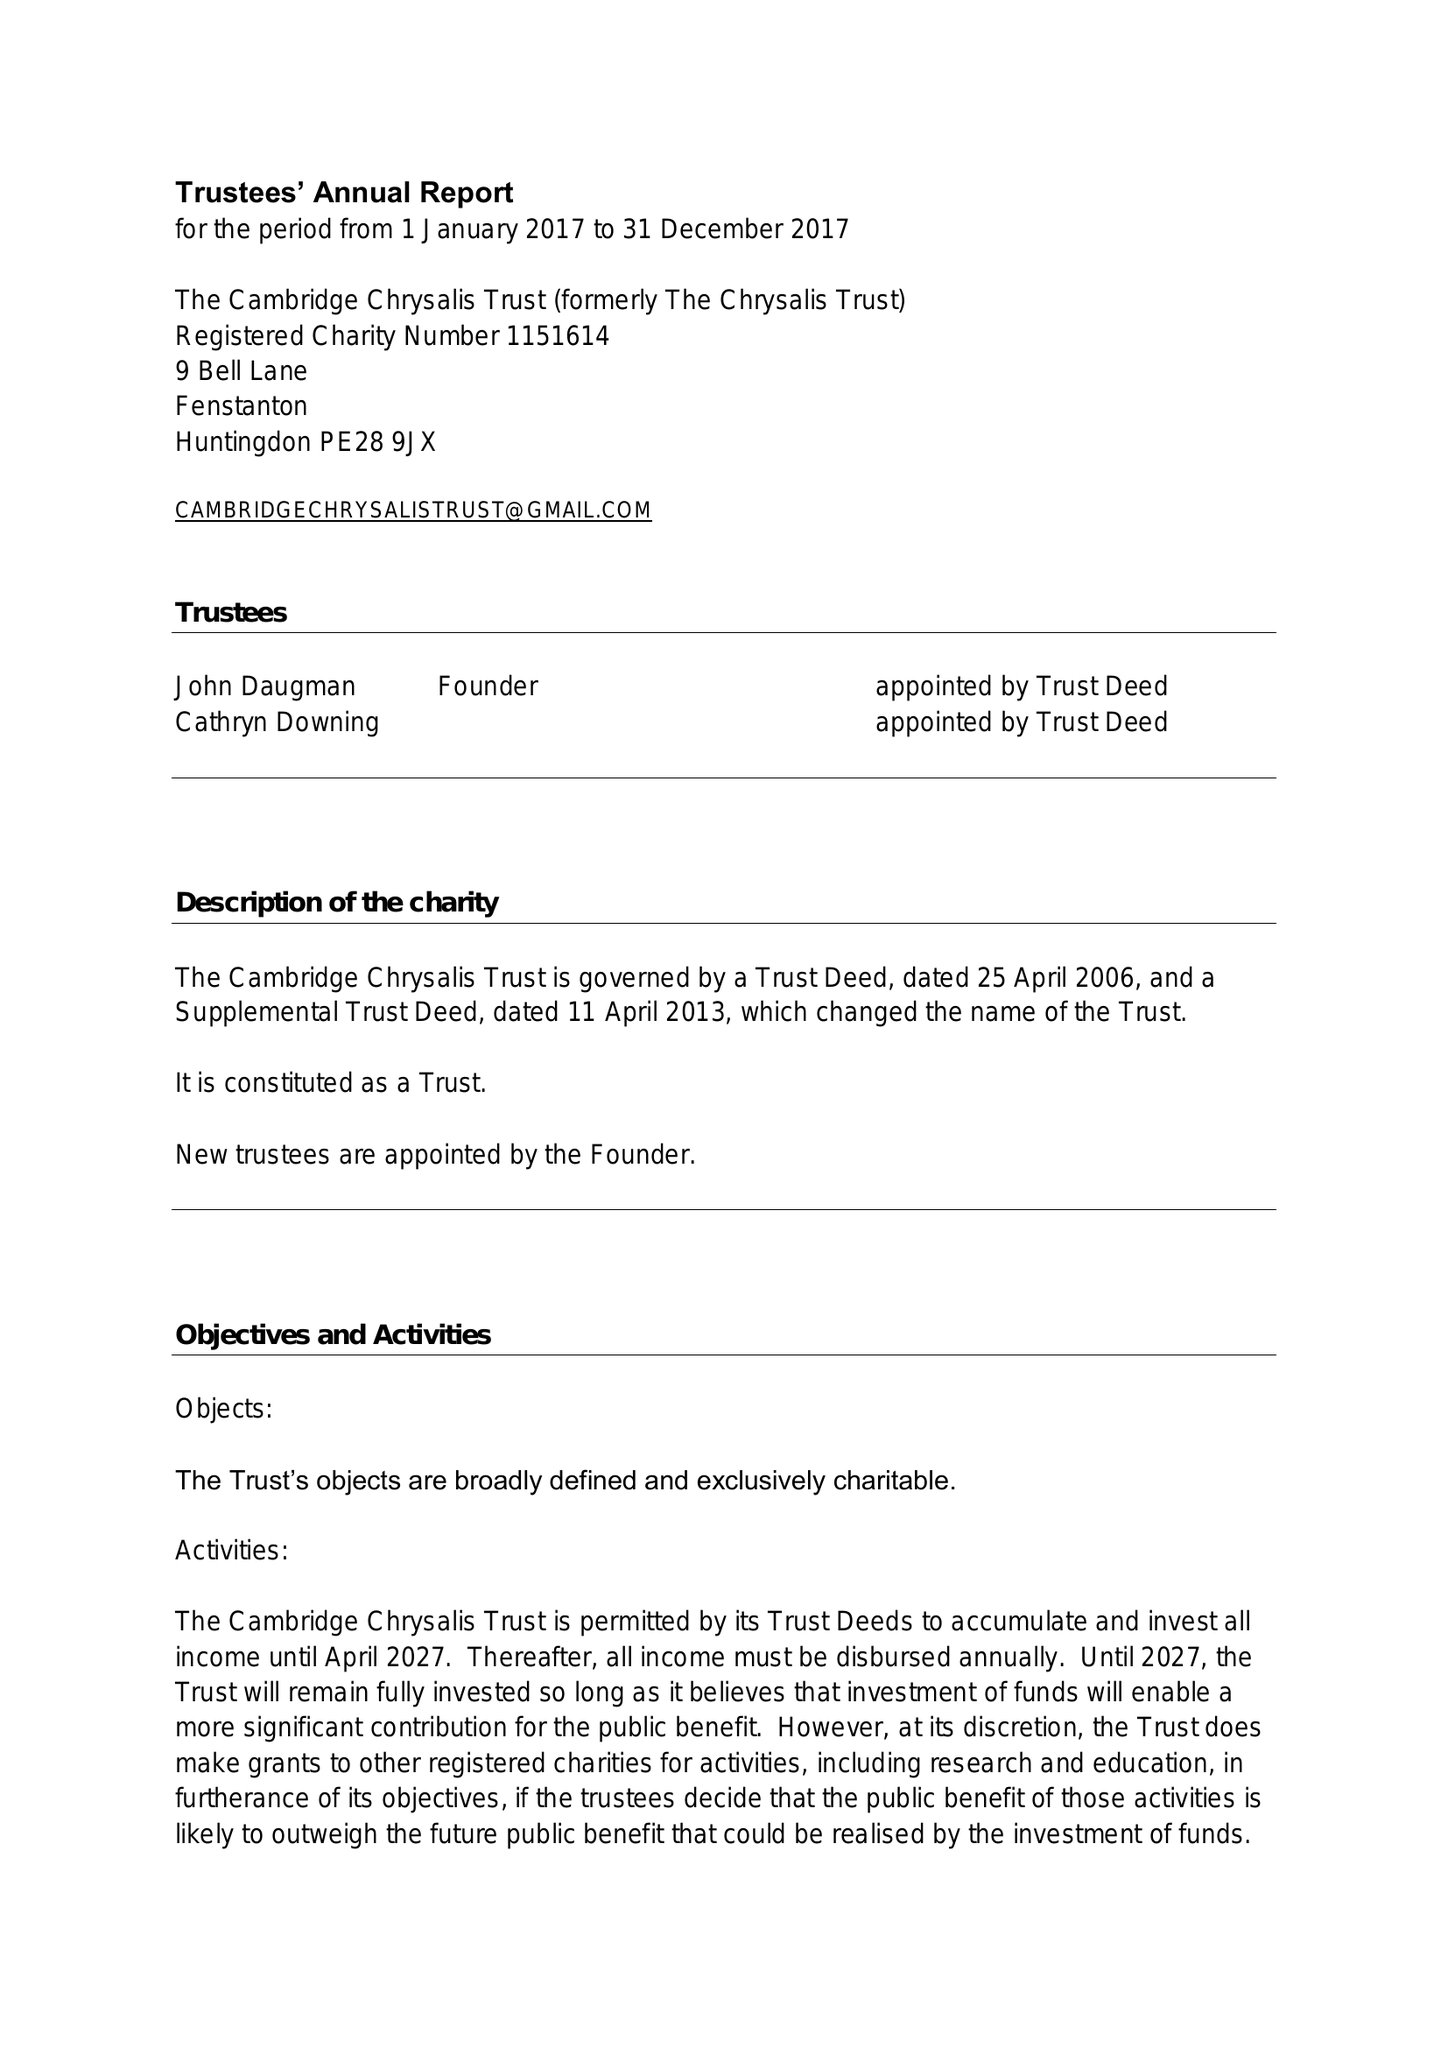What is the value for the address__post_town?
Answer the question using a single word or phrase. HUNTINGDON 